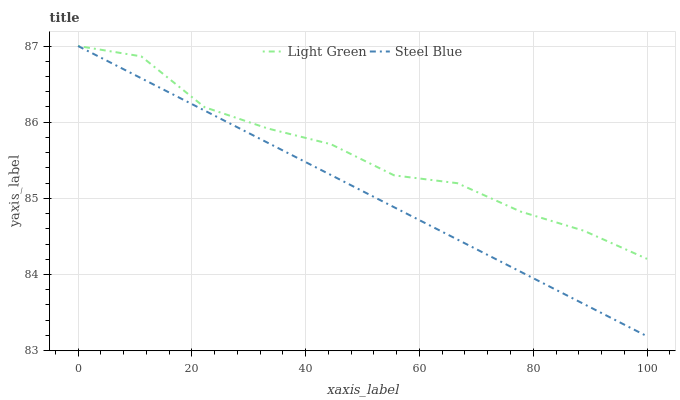Does Steel Blue have the minimum area under the curve?
Answer yes or no. Yes. Does Light Green have the maximum area under the curve?
Answer yes or no. Yes. Does Light Green have the minimum area under the curve?
Answer yes or no. No. Is Steel Blue the smoothest?
Answer yes or no. Yes. Is Light Green the roughest?
Answer yes or no. Yes. Is Light Green the smoothest?
Answer yes or no. No. Does Steel Blue have the lowest value?
Answer yes or no. Yes. Does Light Green have the lowest value?
Answer yes or no. No. Does Light Green have the highest value?
Answer yes or no. Yes. Does Steel Blue intersect Light Green?
Answer yes or no. Yes. Is Steel Blue less than Light Green?
Answer yes or no. No. Is Steel Blue greater than Light Green?
Answer yes or no. No. 